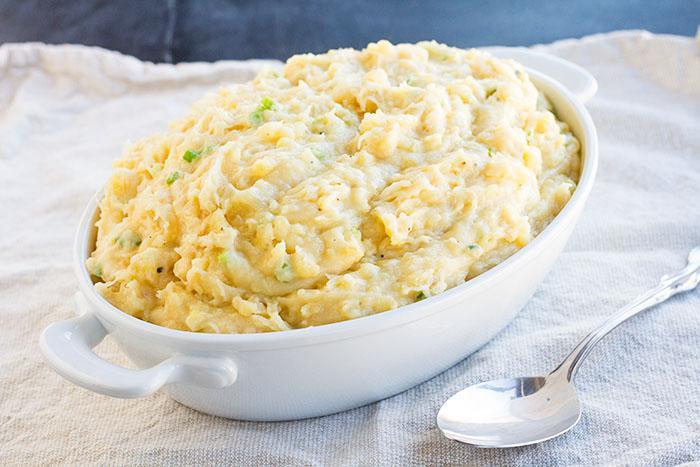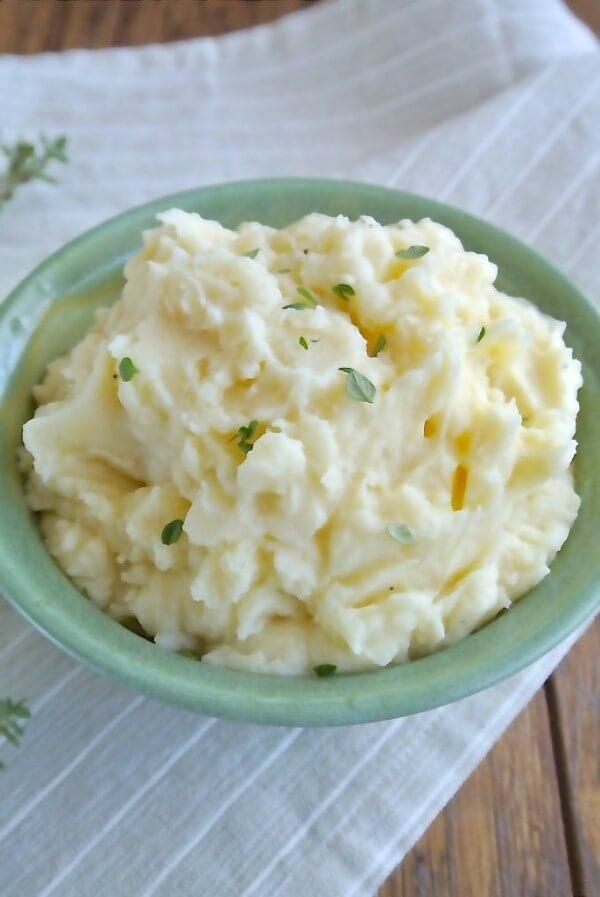The first image is the image on the left, the second image is the image on the right. Considering the images on both sides, is "Some of the mashed potatoes are in a green bowl sitting on top of a striped tablecloth." valid? Answer yes or no. Yes. The first image is the image on the left, the second image is the image on the right. Evaluate the accuracy of this statement regarding the images: "The mashed potatoes in the right image are inside of a white container.". Is it true? Answer yes or no. No. 